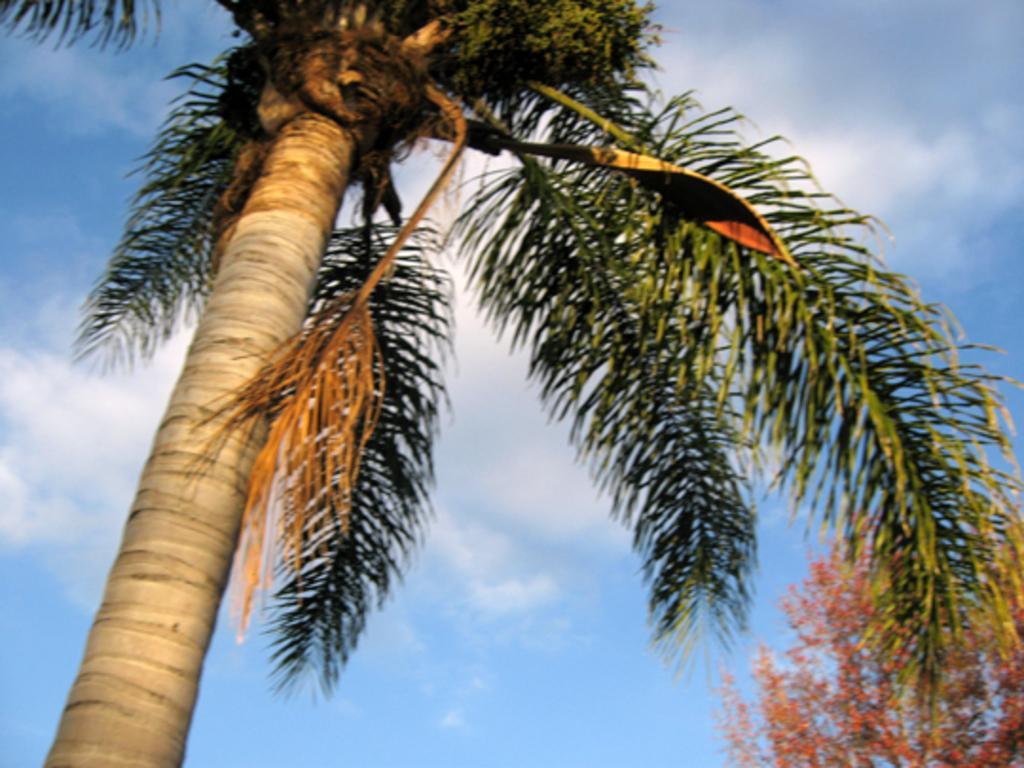Describe this image in one or two sentences. In this image I can see few trees, clouds and the sky. 